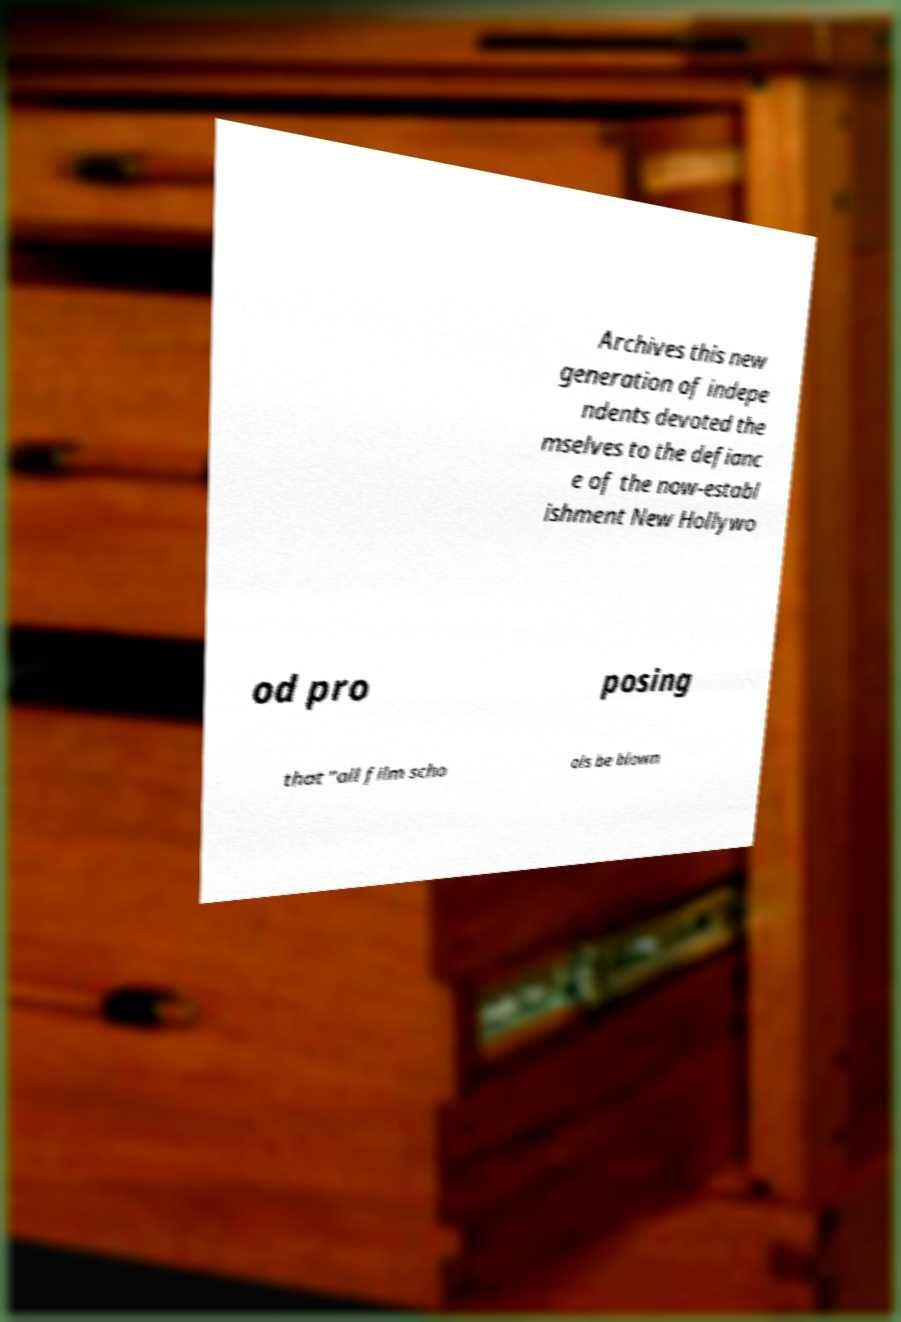Please identify and transcribe the text found in this image. Archives this new generation of indepe ndents devoted the mselves to the defianc e of the now-establ ishment New Hollywo od pro posing that "all film scho ols be blown 